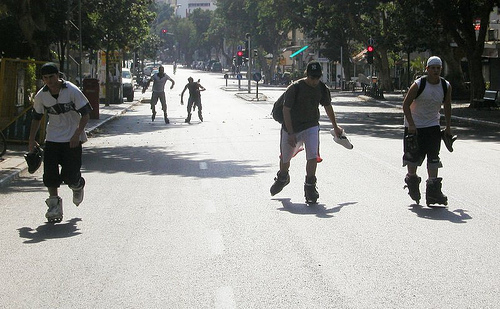What enables these people to go faster on the street?
A. ice skates
B. skate boards
C. roller skates
D. roller blades The individuals are using roller blades, which feature a single line of wheels, to swiftly navigate and gain speed on the street. These are distinct from roller skates, which have two parallel rows of wheels. Roller blades are preferred by many for street skating due to their agility and the ease of maintaining higher speeds. 